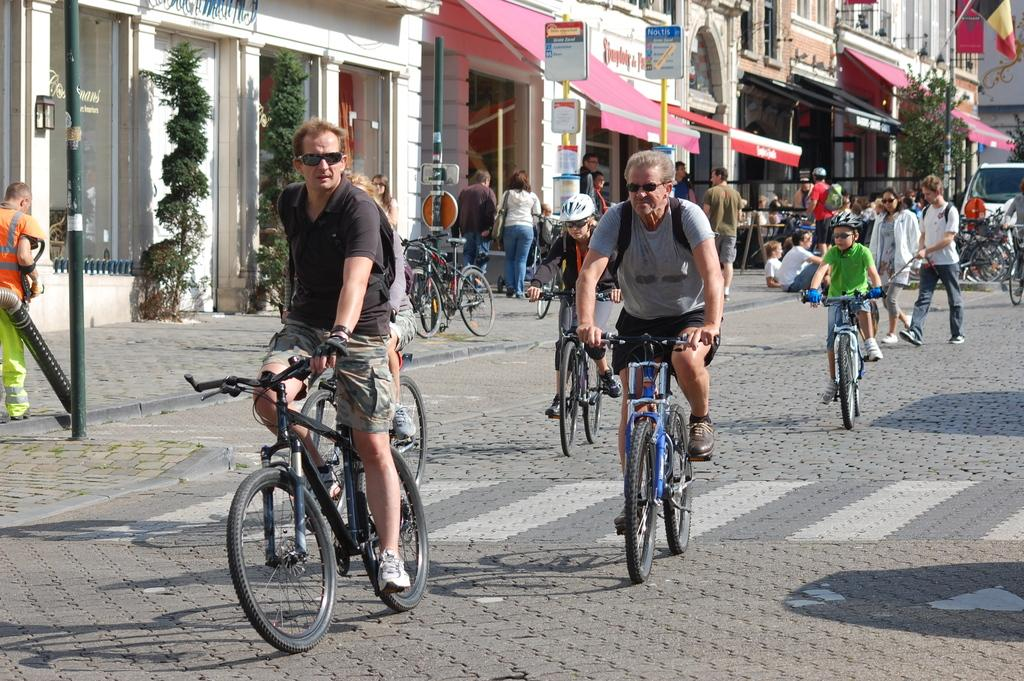Who or what is present in the image? There are people in the image. What are the people doing in the image? The people are riding bicycles. Where are the bicycles located in the image? The bicycles are on a road. What design can be seen on the people's sleeping bags in the image? There are no sleeping bags present in the image; the people are riding bicycles on a road. 